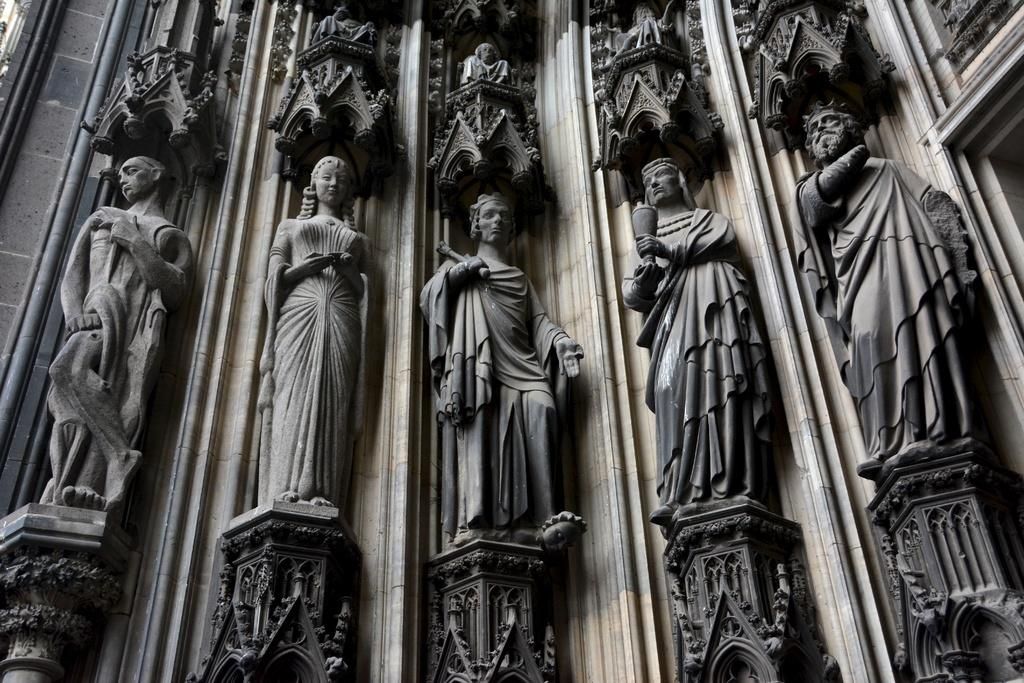What type of objects can be seen in the image? There are statues in the image. Where are the statues located? The statues are on the wall. What type of insurance is required for the statues in the image? There is no information about insurance in the image, as it only shows statues on the wall. 